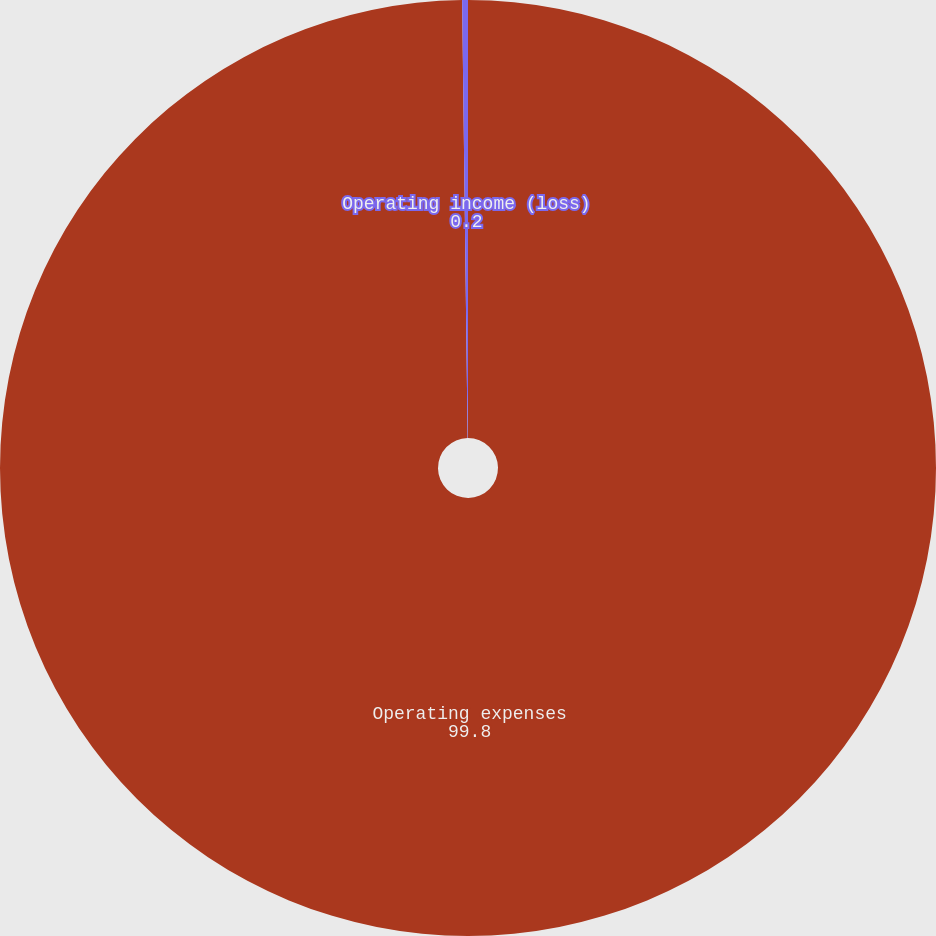Convert chart. <chart><loc_0><loc_0><loc_500><loc_500><pie_chart><fcel>Operating expenses<fcel>Operating income (loss)<nl><fcel>99.8%<fcel>0.2%<nl></chart> 